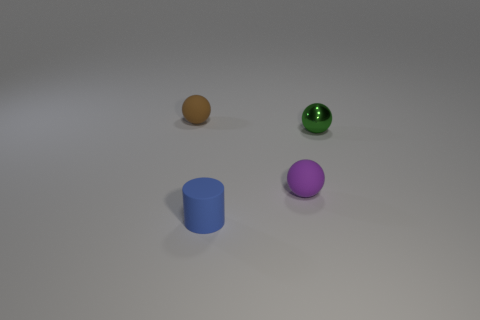There is a blue cylinder that is the same material as the purple ball; what is its size?
Your response must be concise. Small. There is a object behind the tiny green shiny thing; is its shape the same as the tiny purple rubber object?
Make the answer very short. Yes. How many gray objects are either small rubber balls or large matte things?
Your answer should be compact. 0. How many other things are the same shape as the blue rubber thing?
Offer a terse response. 0. The thing that is both right of the blue rubber cylinder and in front of the green object has what shape?
Ensure brevity in your answer.  Sphere. Are there any tiny green things behind the blue matte cylinder?
Make the answer very short. Yes. There is a purple thing that is the same shape as the brown matte object; what size is it?
Provide a short and direct response. Small. Is the shape of the brown thing the same as the purple matte thing?
Your answer should be compact. Yes. What size is the matte ball in front of the tiny rubber ball that is to the left of the matte cylinder?
Give a very brief answer. Small. The other small rubber thing that is the same shape as the purple object is what color?
Keep it short and to the point. Brown. 